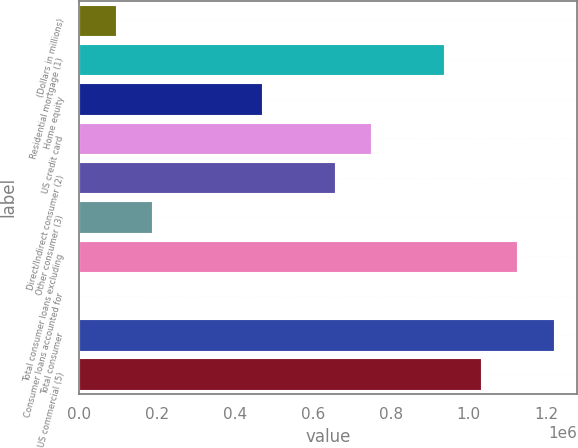<chart> <loc_0><loc_0><loc_500><loc_500><bar_chart><fcel>(Dollars in millions)<fcel>Residential mortgage (1)<fcel>Home equity<fcel>US credit card<fcel>Direct/Indirect consumer (2)<fcel>Other consumer (3)<fcel>Total consumer loans excluding<fcel>Consumer loans accounted for<fcel>Total consumer<fcel>US commercial (5)<nl><fcel>94510.1<fcel>936749<fcel>468838<fcel>749585<fcel>656003<fcel>188092<fcel>1.12391e+06<fcel>928<fcel>1.2175e+06<fcel>1.03033e+06<nl></chart> 